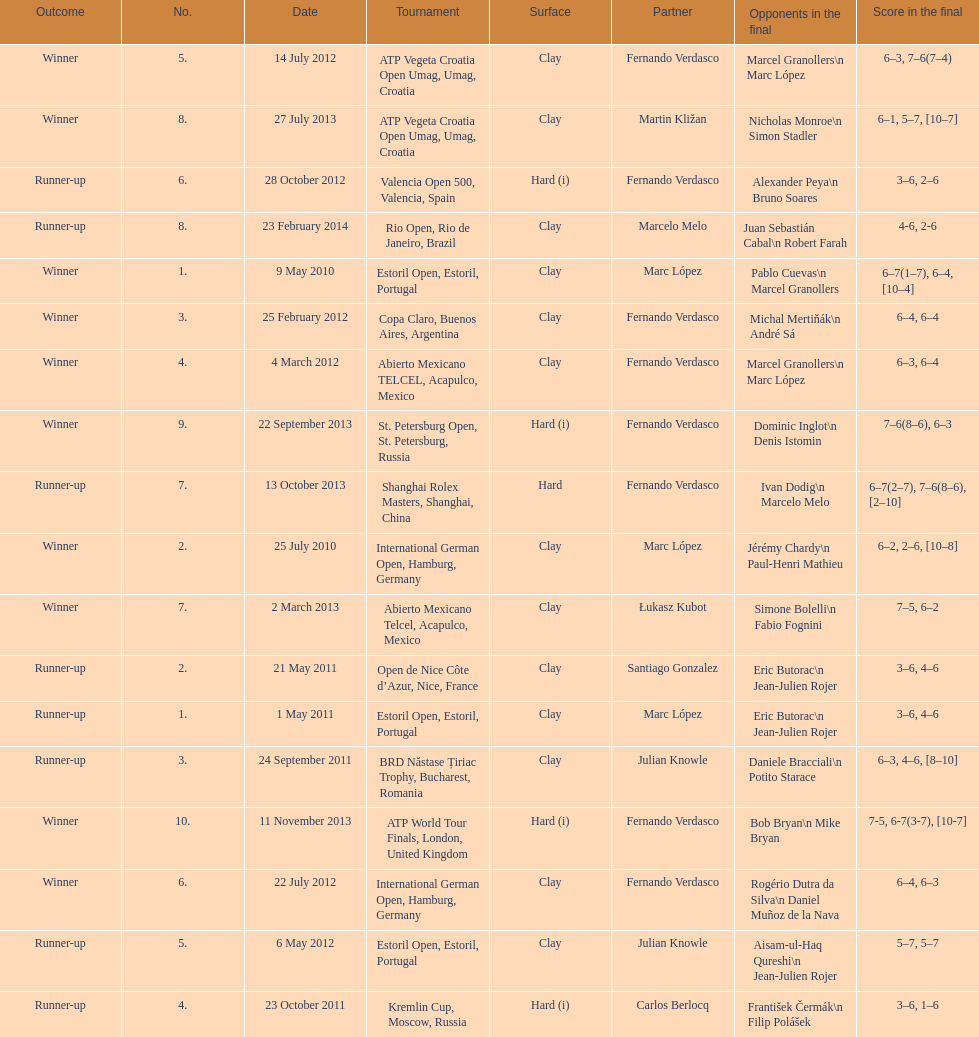How many runner-ups at most are listed? 8. 